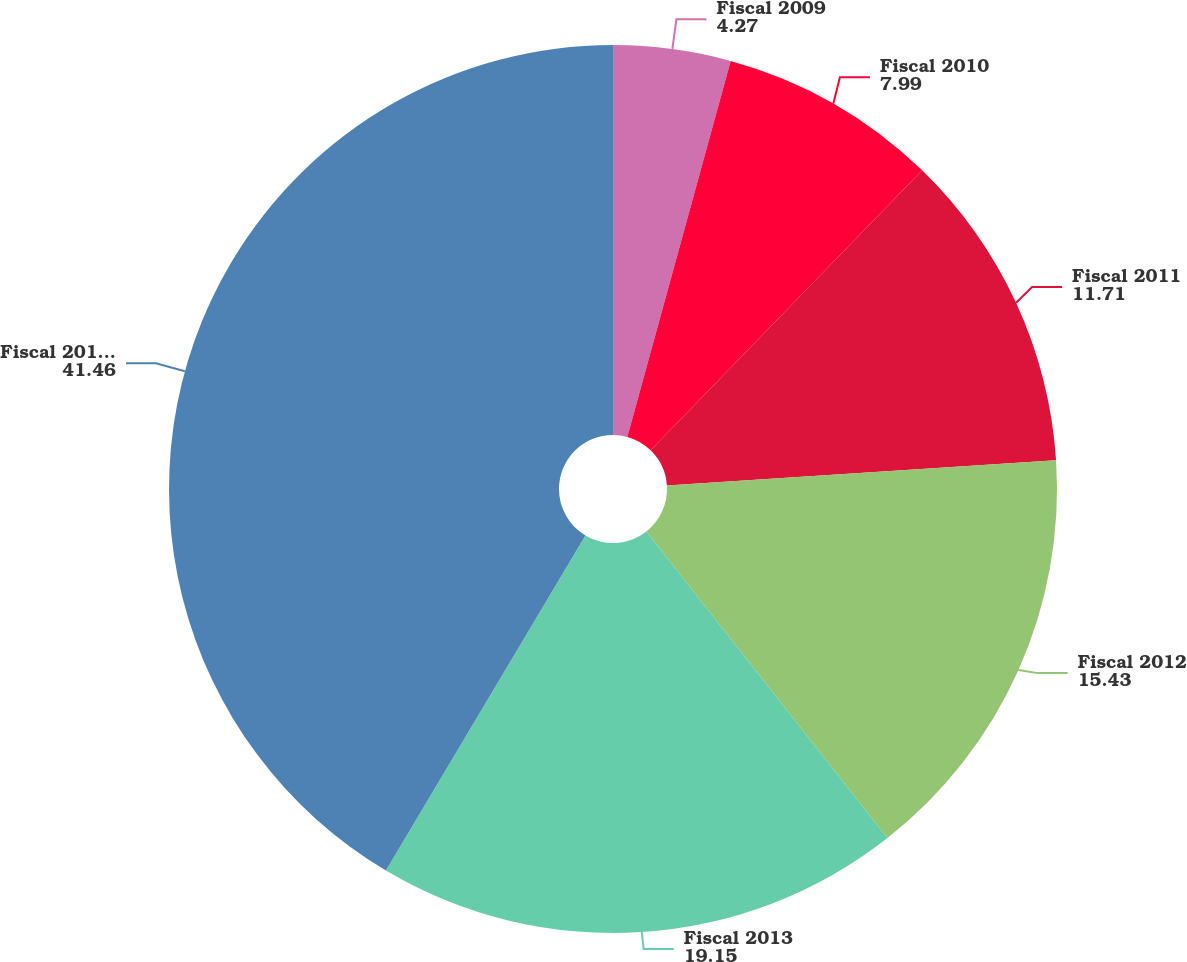<chart> <loc_0><loc_0><loc_500><loc_500><pie_chart><fcel>Fiscal 2009<fcel>Fiscal 2010<fcel>Fiscal 2011<fcel>Fiscal 2012<fcel>Fiscal 2013<fcel>Fiscal 2014 to 2018<nl><fcel>4.27%<fcel>7.99%<fcel>11.71%<fcel>15.43%<fcel>19.15%<fcel>41.46%<nl></chart> 